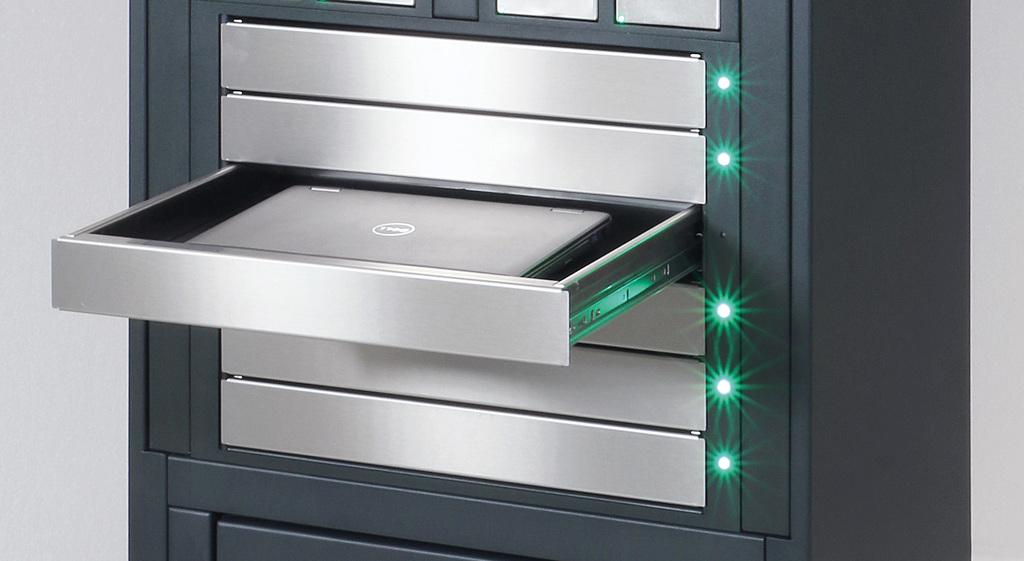What type of furniture or structure is present in the image? There are racks in the image. What electronic device can be seen in the image? There is a laptop in the image. What illuminates the scene in the image? There are lights in the image. What type of architectural feature is visible in the image? There is a wall in the image. Can you see any quivers in the image? There is no quiver present in the image. Are there any insects crawling on the laptop in the image? There is no insect present in the image. 